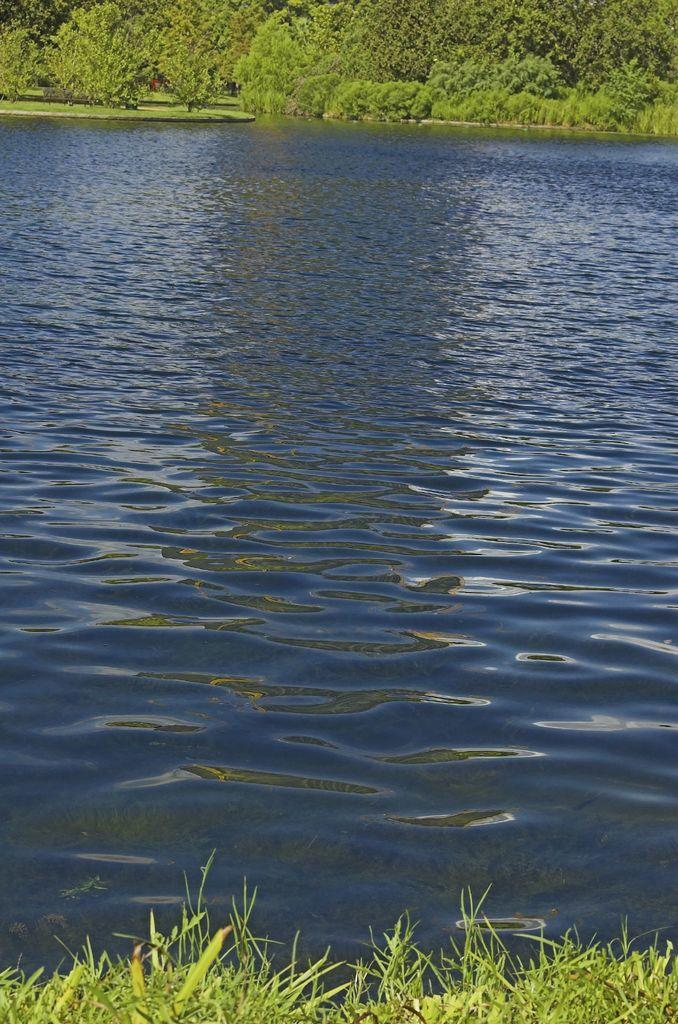What is the primary element visible in the image? There is water in the image. What type of vegetation can be seen in the image? There are trees in the image. What type of ground cover is present at the bottom of the image? There is grass at the bottom of the image. What type of fork can be seen in the image? There is no fork present in the image. What suggestion is being made in the image? There is no suggestion being made in the image; it is a visual representation of water, trees, and grass. 